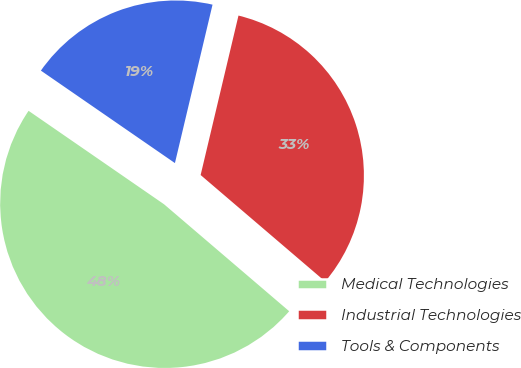Convert chart to OTSL. <chart><loc_0><loc_0><loc_500><loc_500><pie_chart><fcel>Medical Technologies<fcel>Industrial Technologies<fcel>Tools & Components<nl><fcel>48.36%<fcel>32.55%<fcel>19.1%<nl></chart> 